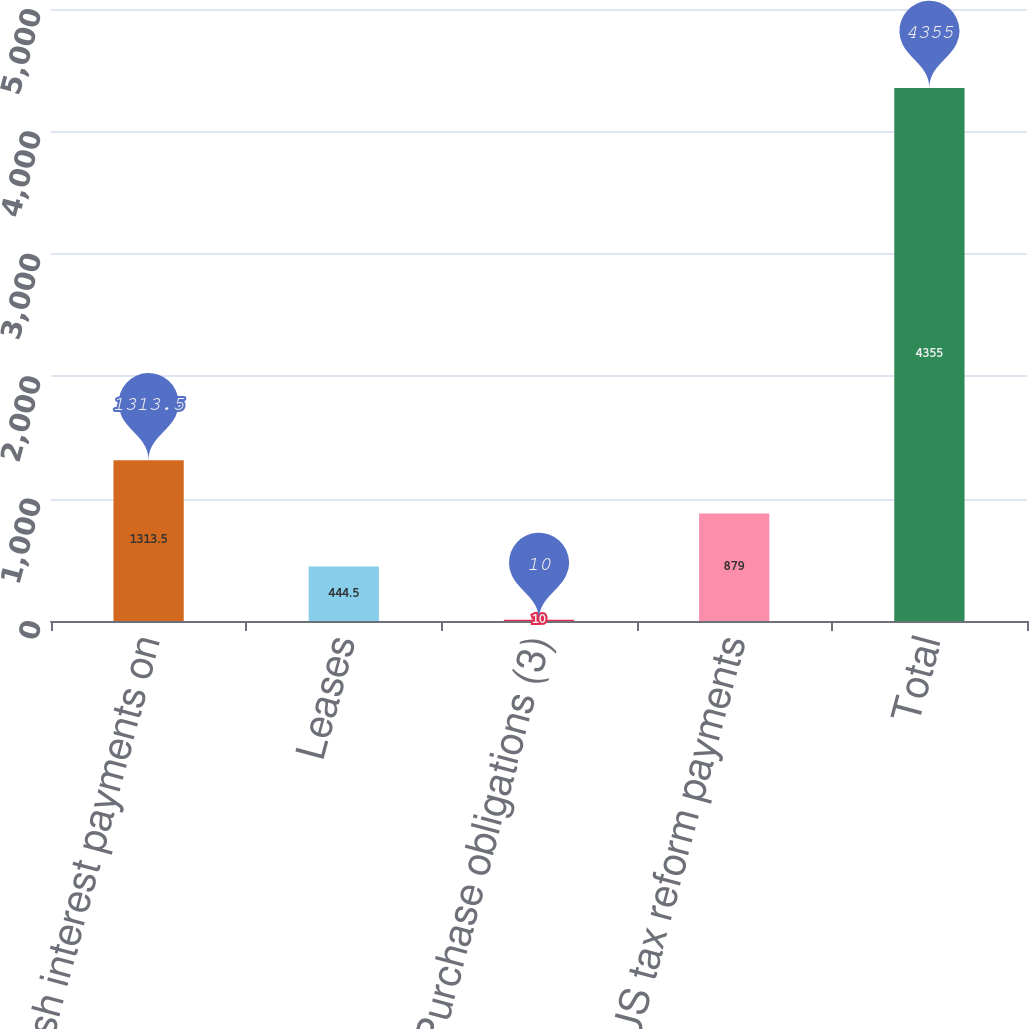Convert chart to OTSL. <chart><loc_0><loc_0><loc_500><loc_500><bar_chart><fcel>Net cash interest payments on<fcel>Leases<fcel>Purchase obligations (3)<fcel>US tax reform payments<fcel>Total<nl><fcel>1313.5<fcel>444.5<fcel>10<fcel>879<fcel>4355<nl></chart> 